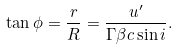Convert formula to latex. <formula><loc_0><loc_0><loc_500><loc_500>\tan \phi = \frac { r } { R } = \frac { u ^ { \prime } } { \Gamma \beta c \sin i } .</formula> 